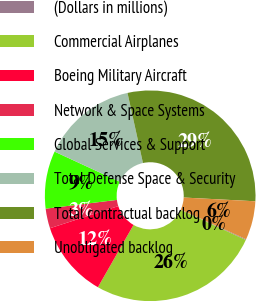Convert chart. <chart><loc_0><loc_0><loc_500><loc_500><pie_chart><fcel>(Dollars in millions)<fcel>Commercial Airplanes<fcel>Boeing Military Aircraft<fcel>Network & Space Systems<fcel>Global Services & Support<fcel>Total Defense Space & Security<fcel>Total contractual backlog<fcel>Unobligated backlog<nl><fcel>0.12%<fcel>26.38%<fcel>11.75%<fcel>3.03%<fcel>8.84%<fcel>14.66%<fcel>29.29%<fcel>5.94%<nl></chart> 